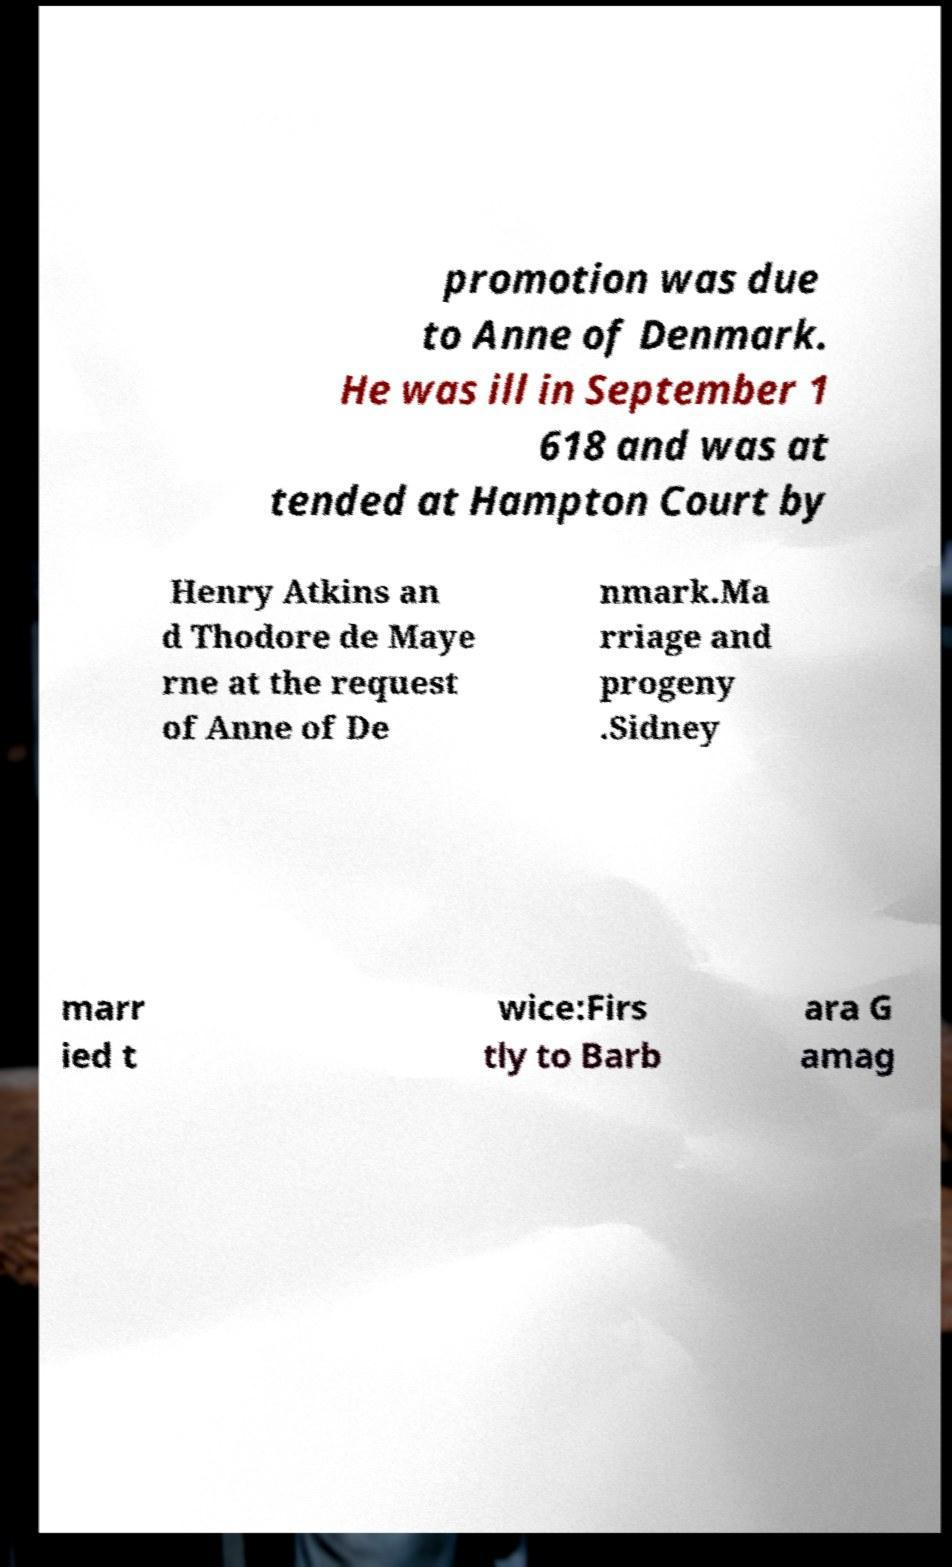I need the written content from this picture converted into text. Can you do that? promotion was due to Anne of Denmark. He was ill in September 1 618 and was at tended at Hampton Court by Henry Atkins an d Thodore de Maye rne at the request of Anne of De nmark.Ma rriage and progeny .Sidney marr ied t wice:Firs tly to Barb ara G amag 